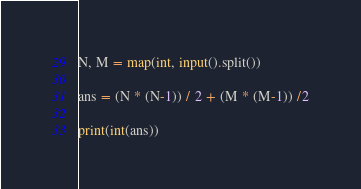Convert code to text. <code><loc_0><loc_0><loc_500><loc_500><_Python_>N, M = map(int, input().split())

ans = (N * (N-1)) / 2 + (M * (M-1)) /2

print(int(ans))</code> 